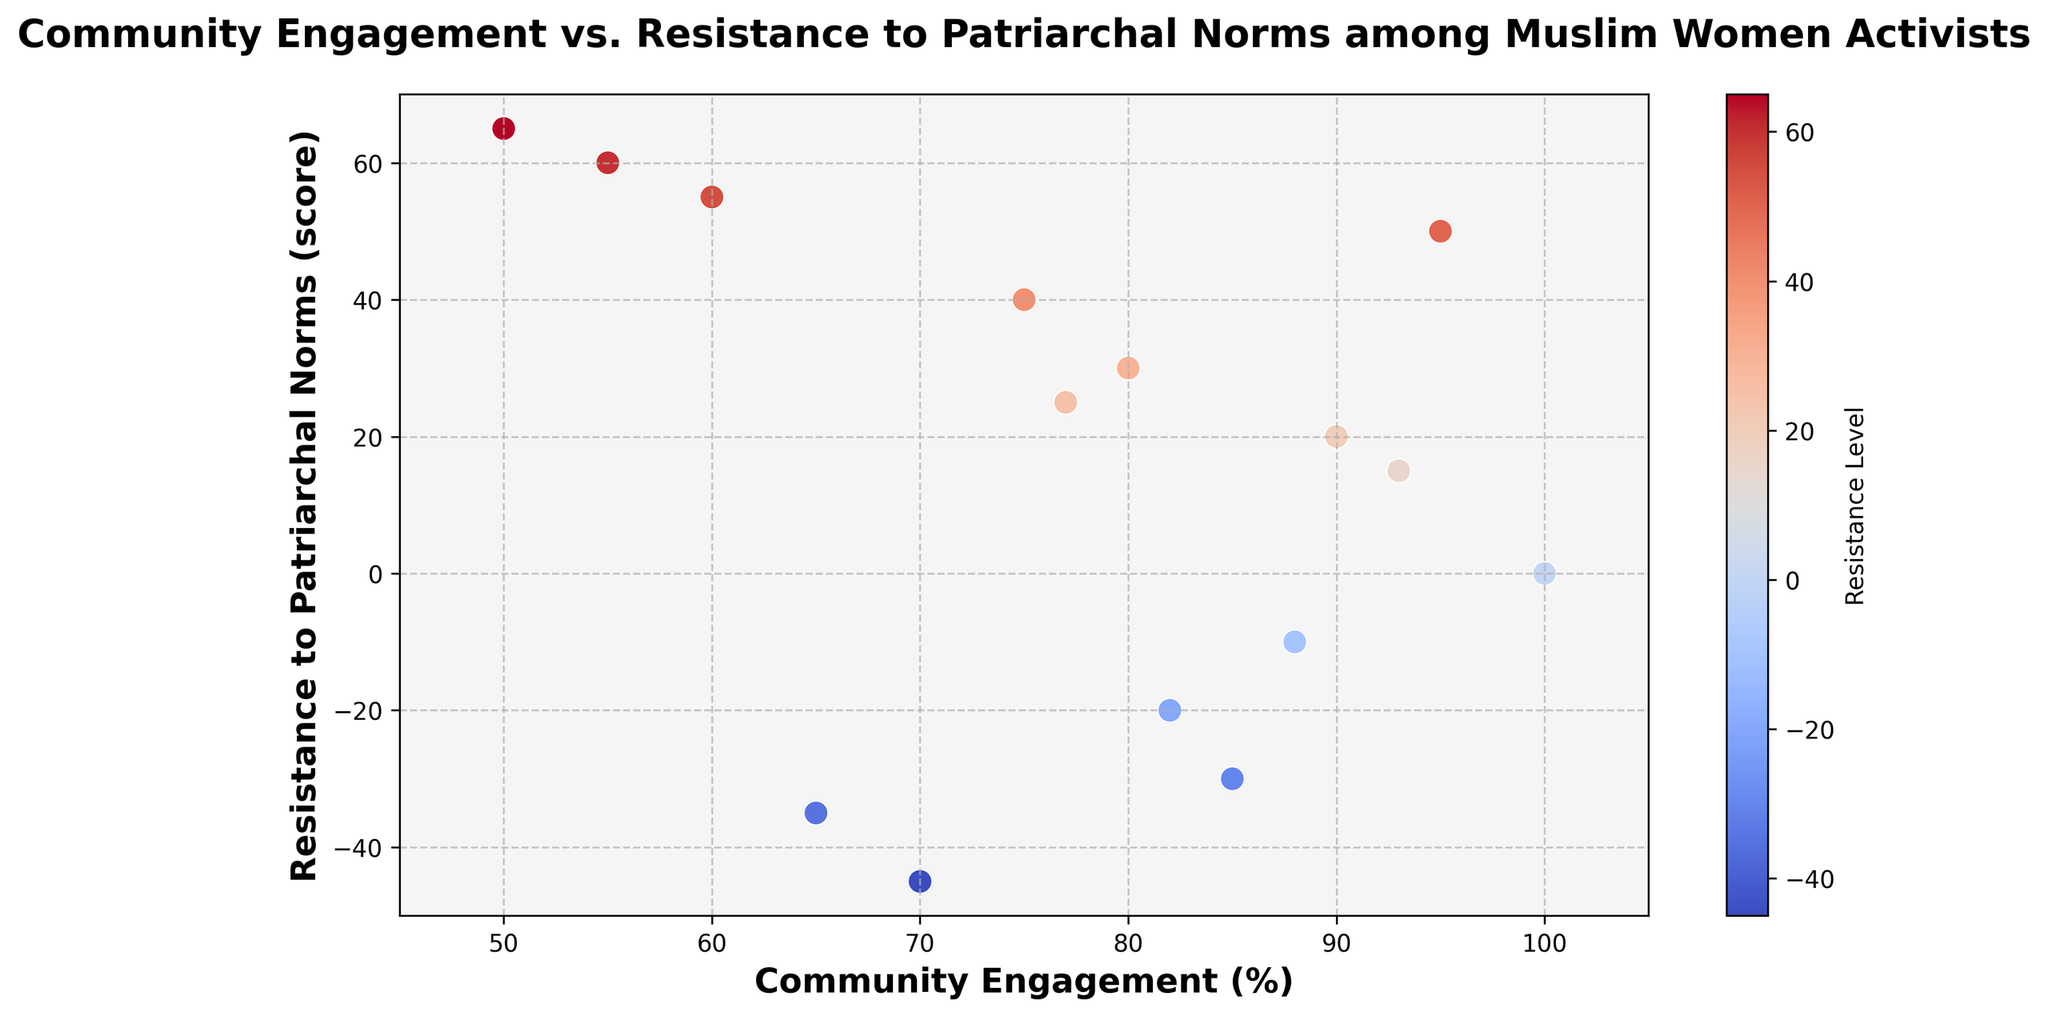What's the highest Resistance to Patriarchal Norms score observed and its corresponding Community Engagement? Looking at the y-axis, the highest score is 65, which corresponds to a Community Engagement of 50%.
Answer: 65, 50% Are there any negative Resistance to Patriarchal Norms scores with high Community Engagement? If yes, what's an example? Checking the plot, negative scores do exist. For instance, -45 corresponds to a Community Engagement of 70%.
Answer: -45, 70% What's the average Community Engagement for the points with positive Resistance to Patriarchal Norms scores? Positive scores: 40, 55, 20, 30, 50, 25, 15, 65. Their corresponding Community Engagement values are: 75, 60, 90, 80, 95, 77, 93, 50. The average is calculated as (75 + 60 + 90 + 80 + 95 + 77 + 93 + 50) / 8 = 77.5.
Answer: 77.5% Between the points with the highest and lowest Community Engagement, how do their Resistance scores compare? The highest Community Engagement is 100% with a Resistance score of 0. The lowest Community Engagement is 50% with a Resistance score of 65. The point with the lowest engagement has a much higher resistance.
Answer: 65 vs 0 Which data point has the darkest blue color, and what does that indicate about its Resistance score? The darkest blue corresponds to the highest positive value in the color bar, indicating a score of 65. This point has the highest resistance.
Answer: 65, 50% Is there a general trend in the data between Community Engagement and Resistance to Patriarchal Norms? Observing the scatter plot, points with higher community engagement tend to have mixed resistance scores, while both positive and negative scores appear regardless of the engagement level. There isn't a clear trend.
Answer: No clear trend What is the median Community Engagement for all points on the scatter plot? Ordering the values: 50, 55, 60, 65, 70, 75, 77, 80, 82, 85, 88, 90, 93, 95, 100. The middle value (median) in this ordered sequence is 77.
Answer: 77% Compare the Resistance scores for Community Engagement values of 82% and 93%. Which is higher? For Community Engagement of 82%, the Resistance score is -20. For 93%, it is 15. Comparing these, 15 is higher than -20.
Answer: 15 is higher What is the sum of the Resistance scores for all points with Community Engagement above 90%? Points: 93 (15), 95 (50), 100 (0). The sum is 15 + 50 + 0 = 65.
Answer: 65 